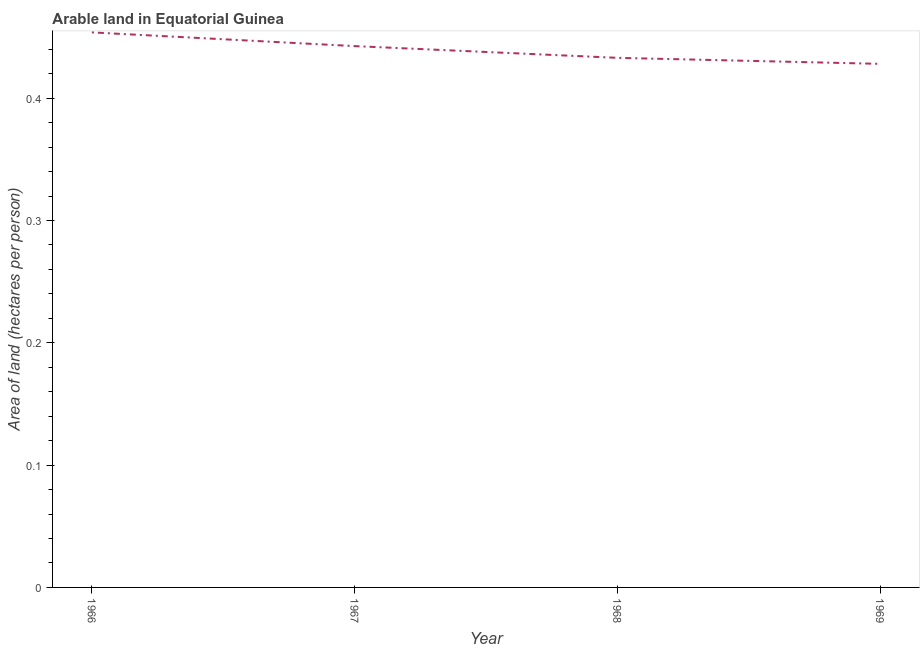What is the area of arable land in 1966?
Offer a terse response. 0.45. Across all years, what is the maximum area of arable land?
Offer a terse response. 0.45. Across all years, what is the minimum area of arable land?
Your answer should be very brief. 0.43. In which year was the area of arable land maximum?
Your answer should be compact. 1966. In which year was the area of arable land minimum?
Offer a terse response. 1969. What is the sum of the area of arable land?
Your answer should be compact. 1.76. What is the difference between the area of arable land in 1966 and 1969?
Provide a short and direct response. 0.03. What is the average area of arable land per year?
Provide a short and direct response. 0.44. What is the median area of arable land?
Give a very brief answer. 0.44. In how many years, is the area of arable land greater than 0.12000000000000001 hectares per person?
Make the answer very short. 4. Do a majority of the years between 1968 and 1969 (inclusive) have area of arable land greater than 0.14 hectares per person?
Offer a very short reply. Yes. What is the ratio of the area of arable land in 1967 to that in 1969?
Your answer should be compact. 1.03. Is the difference between the area of arable land in 1967 and 1968 greater than the difference between any two years?
Keep it short and to the point. No. What is the difference between the highest and the second highest area of arable land?
Ensure brevity in your answer.  0.01. Is the sum of the area of arable land in 1966 and 1969 greater than the maximum area of arable land across all years?
Offer a very short reply. Yes. What is the difference between the highest and the lowest area of arable land?
Ensure brevity in your answer.  0.03. Does the area of arable land monotonically increase over the years?
Ensure brevity in your answer.  No. How many years are there in the graph?
Your answer should be compact. 4. Are the values on the major ticks of Y-axis written in scientific E-notation?
Offer a very short reply. No. Does the graph contain any zero values?
Keep it short and to the point. No. Does the graph contain grids?
Your answer should be compact. No. What is the title of the graph?
Your answer should be very brief. Arable land in Equatorial Guinea. What is the label or title of the Y-axis?
Provide a short and direct response. Area of land (hectares per person). What is the Area of land (hectares per person) of 1966?
Offer a terse response. 0.45. What is the Area of land (hectares per person) in 1967?
Provide a short and direct response. 0.44. What is the Area of land (hectares per person) of 1968?
Give a very brief answer. 0.43. What is the Area of land (hectares per person) of 1969?
Your answer should be very brief. 0.43. What is the difference between the Area of land (hectares per person) in 1966 and 1967?
Make the answer very short. 0.01. What is the difference between the Area of land (hectares per person) in 1966 and 1968?
Your answer should be compact. 0.02. What is the difference between the Area of land (hectares per person) in 1966 and 1969?
Keep it short and to the point. 0.03. What is the difference between the Area of land (hectares per person) in 1967 and 1968?
Offer a very short reply. 0.01. What is the difference between the Area of land (hectares per person) in 1967 and 1969?
Give a very brief answer. 0.01. What is the difference between the Area of land (hectares per person) in 1968 and 1969?
Provide a short and direct response. 0. What is the ratio of the Area of land (hectares per person) in 1966 to that in 1968?
Make the answer very short. 1.05. What is the ratio of the Area of land (hectares per person) in 1966 to that in 1969?
Your answer should be very brief. 1.06. What is the ratio of the Area of land (hectares per person) in 1967 to that in 1968?
Offer a very short reply. 1.02. What is the ratio of the Area of land (hectares per person) in 1967 to that in 1969?
Make the answer very short. 1.03. What is the ratio of the Area of land (hectares per person) in 1968 to that in 1969?
Provide a succinct answer. 1.01. 